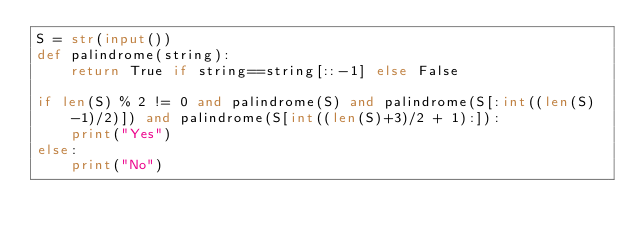<code> <loc_0><loc_0><loc_500><loc_500><_Python_>S = str(input())
def palindrome(string): 
    return True if string==string[::-1] else False
    
if len(S) % 2 != 0 and palindrome(S) and palindrome(S[:int((len(S)-1)/2)]) and palindrome(S[int((len(S)+3)/2 + 1):]):
    print("Yes")
else:
    print("No")</code> 